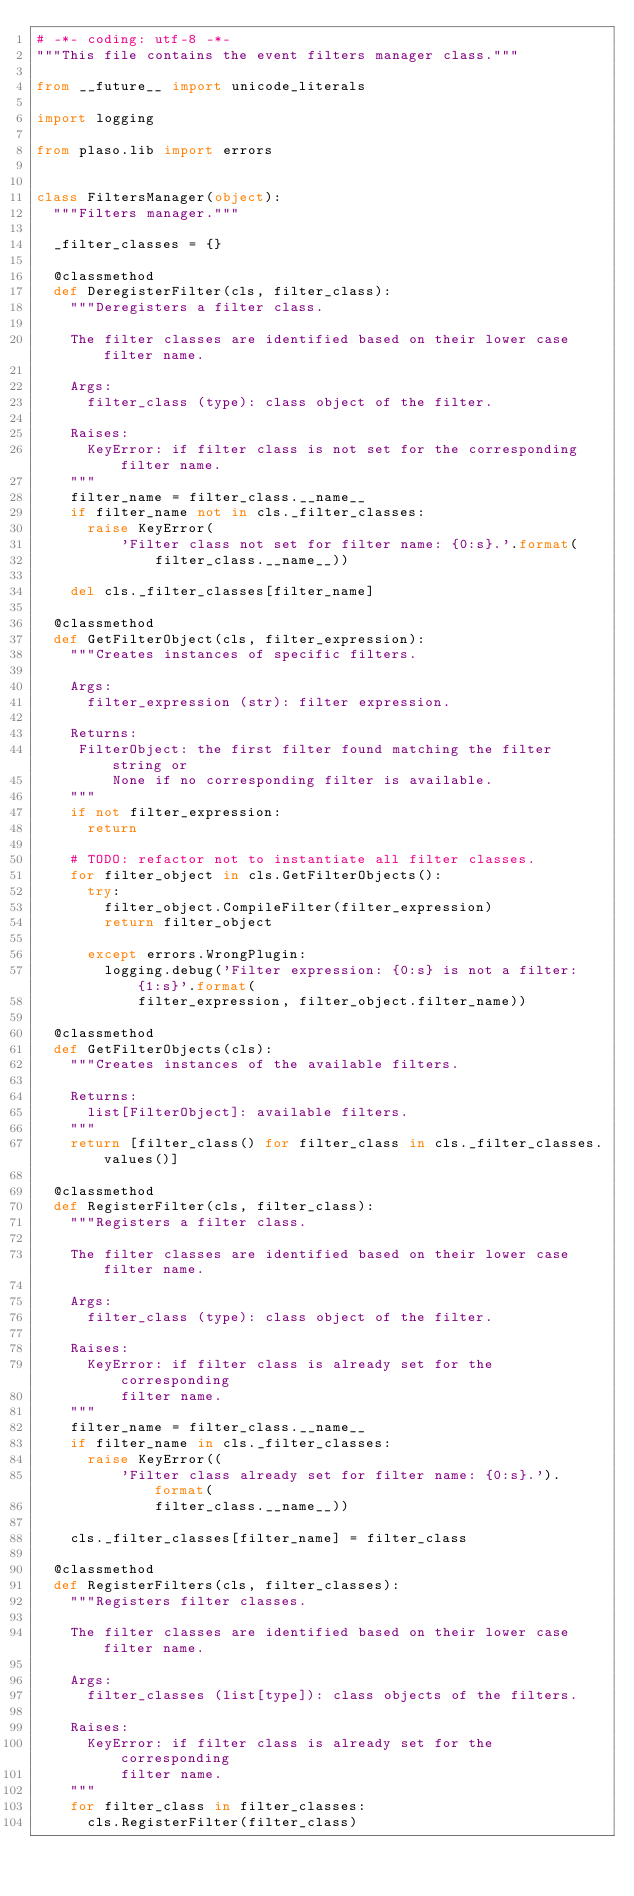<code> <loc_0><loc_0><loc_500><loc_500><_Python_># -*- coding: utf-8 -*-
"""This file contains the event filters manager class."""

from __future__ import unicode_literals

import logging

from plaso.lib import errors


class FiltersManager(object):
  """Filters manager."""

  _filter_classes = {}

  @classmethod
  def DeregisterFilter(cls, filter_class):
    """Deregisters a filter class.

    The filter classes are identified based on their lower case filter name.

    Args:
      filter_class (type): class object of the filter.

    Raises:
      KeyError: if filter class is not set for the corresponding filter name.
    """
    filter_name = filter_class.__name__
    if filter_name not in cls._filter_classes:
      raise KeyError(
          'Filter class not set for filter name: {0:s}.'.format(
              filter_class.__name__))

    del cls._filter_classes[filter_name]

  @classmethod
  def GetFilterObject(cls, filter_expression):
    """Creates instances of specific filters.

    Args:
      filter_expression (str): filter expression.

    Returns:
     FilterObject: the first filter found matching the filter string or
         None if no corresponding filter is available.
    """
    if not filter_expression:
      return

    # TODO: refactor not to instantiate all filter classes.
    for filter_object in cls.GetFilterObjects():
      try:
        filter_object.CompileFilter(filter_expression)
        return filter_object

      except errors.WrongPlugin:
        logging.debug('Filter expression: {0:s} is not a filter: {1:s}'.format(
            filter_expression, filter_object.filter_name))

  @classmethod
  def GetFilterObjects(cls):
    """Creates instances of the available filters.

    Returns:
      list[FilterObject]: available filters.
    """
    return [filter_class() for filter_class in cls._filter_classes.values()]

  @classmethod
  def RegisterFilter(cls, filter_class):
    """Registers a filter class.

    The filter classes are identified based on their lower case filter name.

    Args:
      filter_class (type): class object of the filter.

    Raises:
      KeyError: if filter class is already set for the corresponding
          filter name.
    """
    filter_name = filter_class.__name__
    if filter_name in cls._filter_classes:
      raise KeyError((
          'Filter class already set for filter name: {0:s}.').format(
              filter_class.__name__))

    cls._filter_classes[filter_name] = filter_class

  @classmethod
  def RegisterFilters(cls, filter_classes):
    """Registers filter classes.

    The filter classes are identified based on their lower case filter name.

    Args:
      filter_classes (list[type]): class objects of the filters.

    Raises:
      KeyError: if filter class is already set for the corresponding
          filter name.
    """
    for filter_class in filter_classes:
      cls.RegisterFilter(filter_class)
</code> 